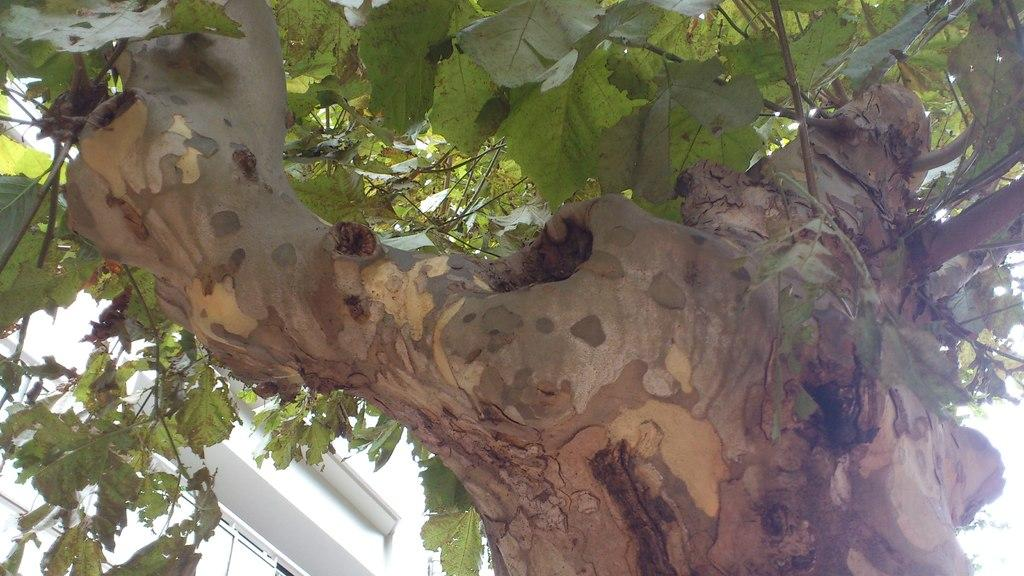What type of natural element is present in the image? There is a tree in the image. Can you tell me how many eyes are visible on the tree in the image? There are no eyes visible on the tree in the image, as trees do not have eyes. 